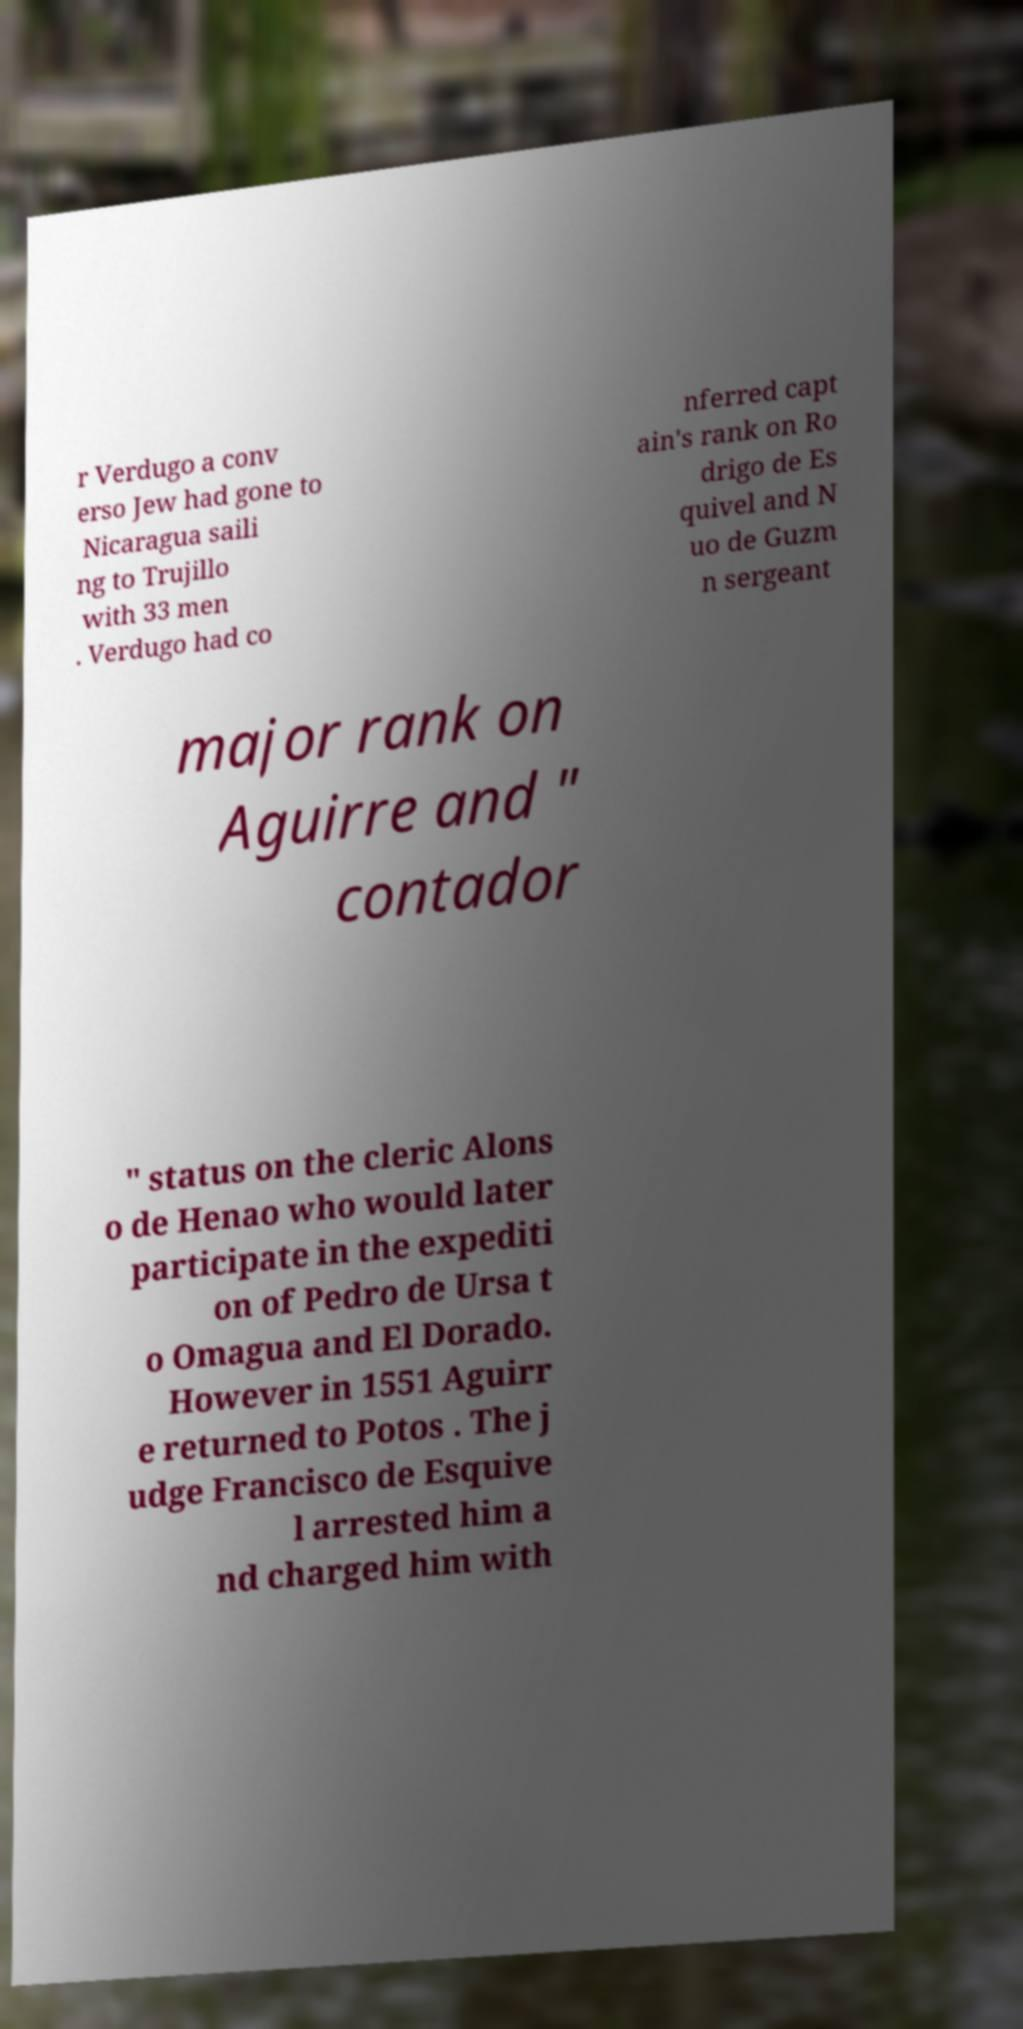What messages or text are displayed in this image? I need them in a readable, typed format. r Verdugo a conv erso Jew had gone to Nicaragua saili ng to Trujillo with 33 men . Verdugo had co nferred capt ain's rank on Ro drigo de Es quivel and N uo de Guzm n sergeant major rank on Aguirre and " contador " status on the cleric Alons o de Henao who would later participate in the expediti on of Pedro de Ursa t o Omagua and El Dorado. However in 1551 Aguirr e returned to Potos . The j udge Francisco de Esquive l arrested him a nd charged him with 